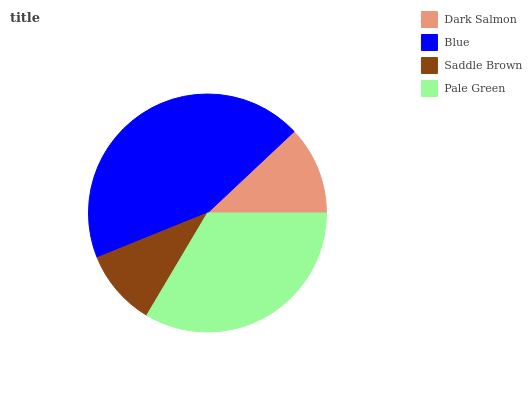Is Saddle Brown the minimum?
Answer yes or no. Yes. Is Blue the maximum?
Answer yes or no. Yes. Is Blue the minimum?
Answer yes or no. No. Is Saddle Brown the maximum?
Answer yes or no. No. Is Blue greater than Saddle Brown?
Answer yes or no. Yes. Is Saddle Brown less than Blue?
Answer yes or no. Yes. Is Saddle Brown greater than Blue?
Answer yes or no. No. Is Blue less than Saddle Brown?
Answer yes or no. No. Is Pale Green the high median?
Answer yes or no. Yes. Is Dark Salmon the low median?
Answer yes or no. Yes. Is Dark Salmon the high median?
Answer yes or no. No. Is Saddle Brown the low median?
Answer yes or no. No. 